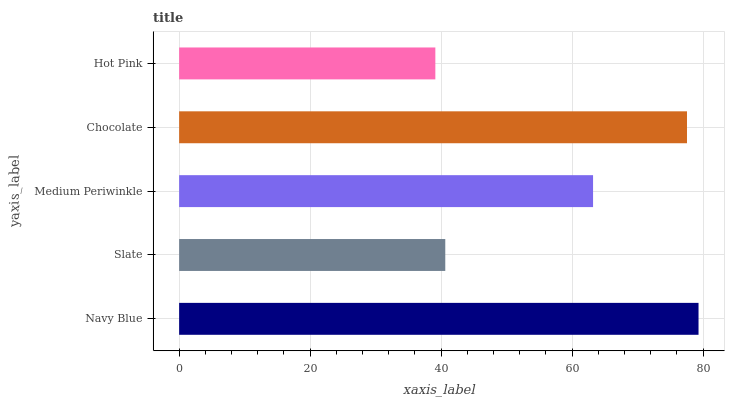Is Hot Pink the minimum?
Answer yes or no. Yes. Is Navy Blue the maximum?
Answer yes or no. Yes. Is Slate the minimum?
Answer yes or no. No. Is Slate the maximum?
Answer yes or no. No. Is Navy Blue greater than Slate?
Answer yes or no. Yes. Is Slate less than Navy Blue?
Answer yes or no. Yes. Is Slate greater than Navy Blue?
Answer yes or no. No. Is Navy Blue less than Slate?
Answer yes or no. No. Is Medium Periwinkle the high median?
Answer yes or no. Yes. Is Medium Periwinkle the low median?
Answer yes or no. Yes. Is Navy Blue the high median?
Answer yes or no. No. Is Chocolate the low median?
Answer yes or no. No. 